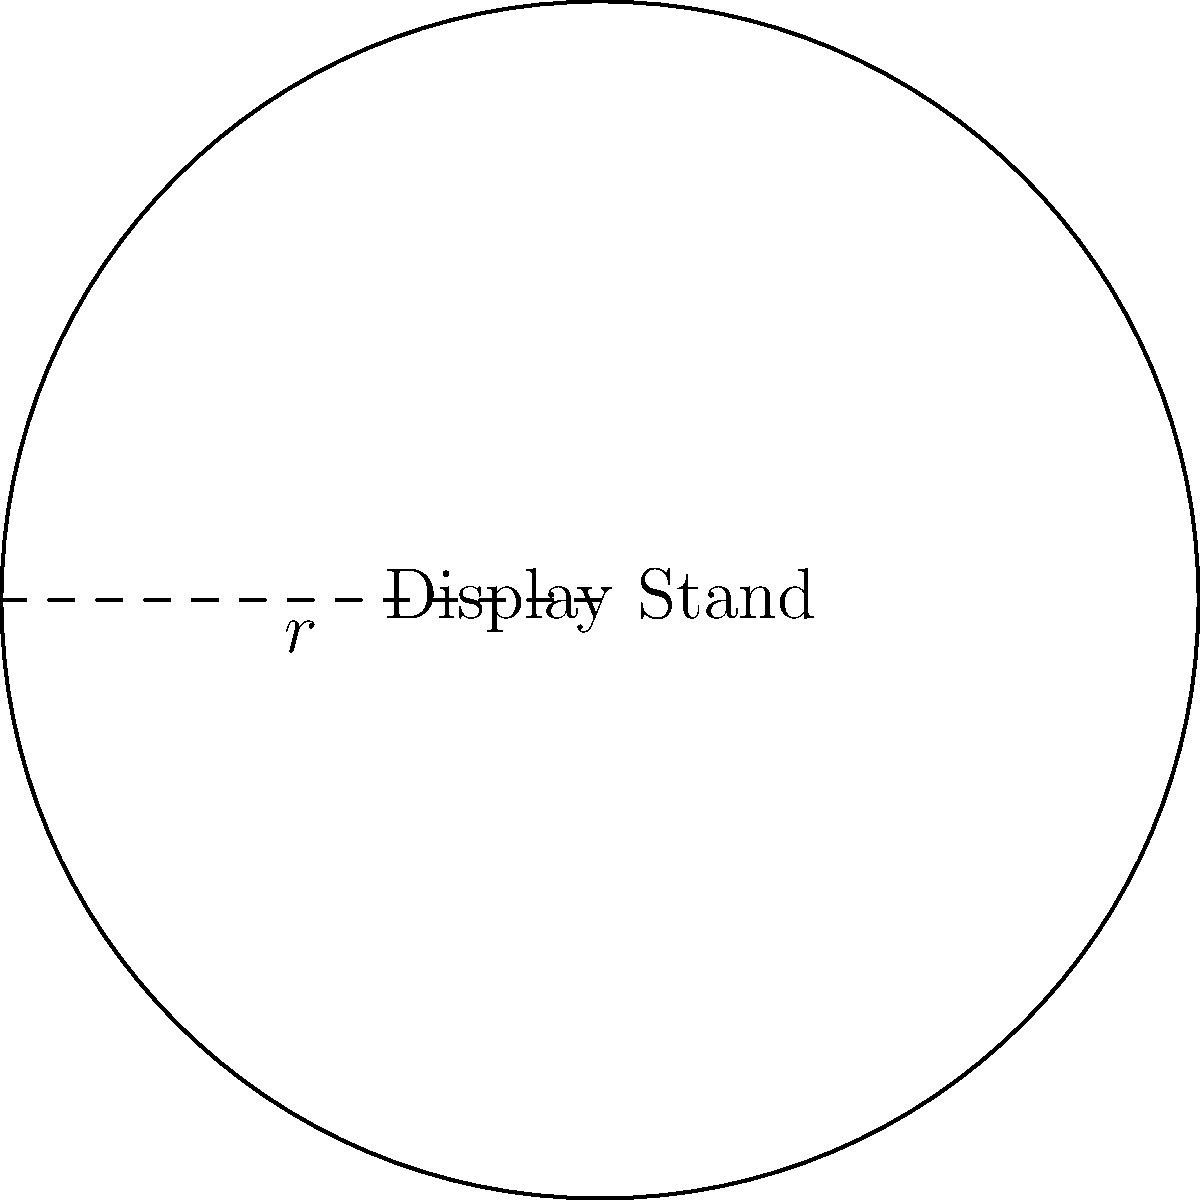You have a circular display stand for your convenience store's new snack promotion. If the radius of the stand is 2 feet, what is the total area available for displaying products? To calculate the area of a circular display stand, we use the formula for the area of a circle:

$$A = \pi r^2$$

Where:
$A$ = area of the circle
$\pi$ = pi (approximately 3.14159)
$r$ = radius of the circle

Given:
$r = 2$ feet

Step 1: Substitute the given radius into the formula.
$$A = \pi (2)^2$$

Step 2: Calculate the square of the radius.
$$A = \pi (4)$$

Step 3: Multiply by π.
$$A = 4\pi \approx 12.57$$

Therefore, the total area available for displaying products is approximately 12.57 square feet.
Answer: $4\pi$ sq ft (≈ 12.57 sq ft) 